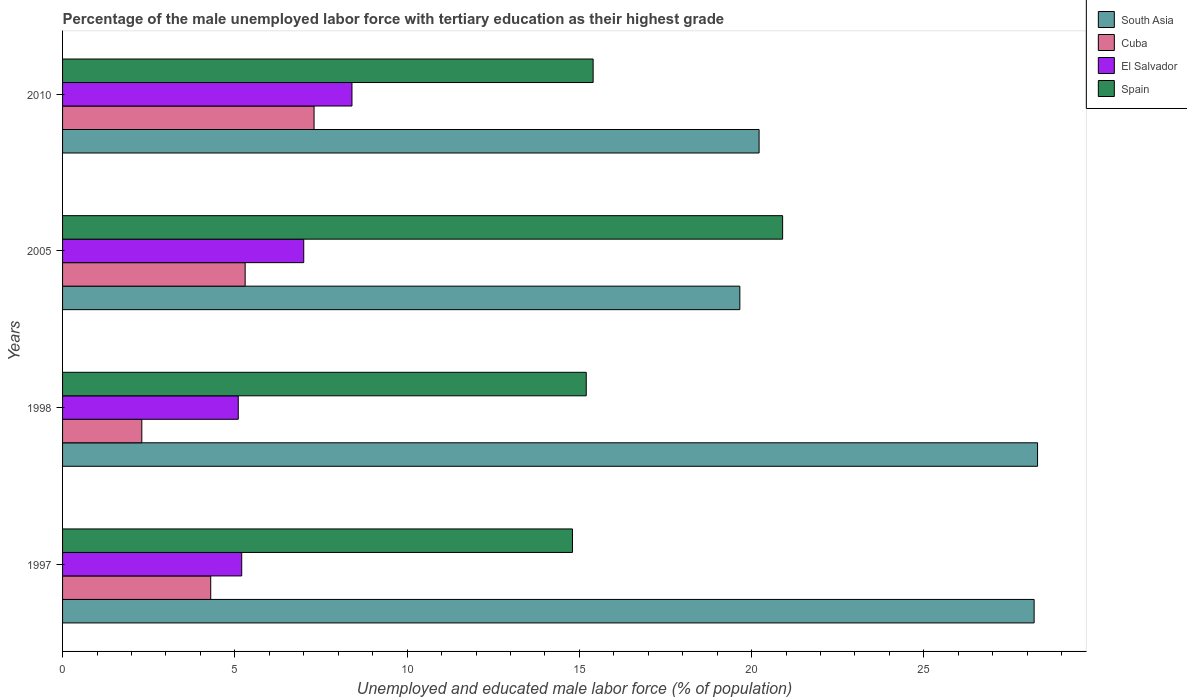How many different coloured bars are there?
Your answer should be compact. 4. How many groups of bars are there?
Offer a terse response. 4. Are the number of bars per tick equal to the number of legend labels?
Offer a terse response. Yes. Are the number of bars on each tick of the Y-axis equal?
Your response must be concise. Yes. How many bars are there on the 1st tick from the top?
Your answer should be compact. 4. In how many cases, is the number of bars for a given year not equal to the number of legend labels?
Your response must be concise. 0. What is the percentage of the unemployed male labor force with tertiary education in El Salvador in 2010?
Offer a terse response. 8.4. Across all years, what is the maximum percentage of the unemployed male labor force with tertiary education in El Salvador?
Offer a very short reply. 8.4. Across all years, what is the minimum percentage of the unemployed male labor force with tertiary education in South Asia?
Ensure brevity in your answer.  19.66. In which year was the percentage of the unemployed male labor force with tertiary education in Cuba minimum?
Your response must be concise. 1998. What is the total percentage of the unemployed male labor force with tertiary education in Spain in the graph?
Your answer should be compact. 66.3. What is the difference between the percentage of the unemployed male labor force with tertiary education in Cuba in 1997 and that in 1998?
Give a very brief answer. 2. What is the difference between the percentage of the unemployed male labor force with tertiary education in Spain in 2010 and the percentage of the unemployed male labor force with tertiary education in El Salvador in 1998?
Offer a very short reply. 10.3. What is the average percentage of the unemployed male labor force with tertiary education in South Asia per year?
Offer a very short reply. 24.09. In the year 1997, what is the difference between the percentage of the unemployed male labor force with tertiary education in Cuba and percentage of the unemployed male labor force with tertiary education in South Asia?
Your response must be concise. -23.9. What is the ratio of the percentage of the unemployed male labor force with tertiary education in Spain in 1998 to that in 2005?
Offer a very short reply. 0.73. What is the difference between the highest and the second highest percentage of the unemployed male labor force with tertiary education in Spain?
Your answer should be very brief. 5.5. What is the difference between the highest and the lowest percentage of the unemployed male labor force with tertiary education in Cuba?
Your answer should be compact. 5. In how many years, is the percentage of the unemployed male labor force with tertiary education in South Asia greater than the average percentage of the unemployed male labor force with tertiary education in South Asia taken over all years?
Make the answer very short. 2. What does the 4th bar from the bottom in 1998 represents?
Your answer should be compact. Spain. Is it the case that in every year, the sum of the percentage of the unemployed male labor force with tertiary education in El Salvador and percentage of the unemployed male labor force with tertiary education in Cuba is greater than the percentage of the unemployed male labor force with tertiary education in South Asia?
Offer a very short reply. No. How many bars are there?
Offer a very short reply. 16. Are all the bars in the graph horizontal?
Your answer should be very brief. Yes. How many years are there in the graph?
Offer a very short reply. 4. Are the values on the major ticks of X-axis written in scientific E-notation?
Offer a terse response. No. Does the graph contain grids?
Your response must be concise. No. What is the title of the graph?
Offer a terse response. Percentage of the male unemployed labor force with tertiary education as their highest grade. What is the label or title of the X-axis?
Provide a succinct answer. Unemployed and educated male labor force (% of population). What is the Unemployed and educated male labor force (% of population) in South Asia in 1997?
Offer a very short reply. 28.2. What is the Unemployed and educated male labor force (% of population) of Cuba in 1997?
Your response must be concise. 4.3. What is the Unemployed and educated male labor force (% of population) of El Salvador in 1997?
Offer a very short reply. 5.2. What is the Unemployed and educated male labor force (% of population) of Spain in 1997?
Offer a terse response. 14.8. What is the Unemployed and educated male labor force (% of population) of South Asia in 1998?
Your response must be concise. 28.3. What is the Unemployed and educated male labor force (% of population) of Cuba in 1998?
Give a very brief answer. 2.3. What is the Unemployed and educated male labor force (% of population) in El Salvador in 1998?
Offer a very short reply. 5.1. What is the Unemployed and educated male labor force (% of population) in Spain in 1998?
Give a very brief answer. 15.2. What is the Unemployed and educated male labor force (% of population) of South Asia in 2005?
Offer a terse response. 19.66. What is the Unemployed and educated male labor force (% of population) of Cuba in 2005?
Give a very brief answer. 5.3. What is the Unemployed and educated male labor force (% of population) in El Salvador in 2005?
Give a very brief answer. 7. What is the Unemployed and educated male labor force (% of population) of Spain in 2005?
Give a very brief answer. 20.9. What is the Unemployed and educated male labor force (% of population) of South Asia in 2010?
Your response must be concise. 20.22. What is the Unemployed and educated male labor force (% of population) in Cuba in 2010?
Ensure brevity in your answer.  7.3. What is the Unemployed and educated male labor force (% of population) of El Salvador in 2010?
Offer a very short reply. 8.4. What is the Unemployed and educated male labor force (% of population) in Spain in 2010?
Offer a terse response. 15.4. Across all years, what is the maximum Unemployed and educated male labor force (% of population) in South Asia?
Provide a short and direct response. 28.3. Across all years, what is the maximum Unemployed and educated male labor force (% of population) in Cuba?
Your answer should be very brief. 7.3. Across all years, what is the maximum Unemployed and educated male labor force (% of population) of El Salvador?
Provide a short and direct response. 8.4. Across all years, what is the maximum Unemployed and educated male labor force (% of population) of Spain?
Ensure brevity in your answer.  20.9. Across all years, what is the minimum Unemployed and educated male labor force (% of population) in South Asia?
Keep it short and to the point. 19.66. Across all years, what is the minimum Unemployed and educated male labor force (% of population) of Cuba?
Your response must be concise. 2.3. Across all years, what is the minimum Unemployed and educated male labor force (% of population) in El Salvador?
Offer a terse response. 5.1. Across all years, what is the minimum Unemployed and educated male labor force (% of population) of Spain?
Ensure brevity in your answer.  14.8. What is the total Unemployed and educated male labor force (% of population) in South Asia in the graph?
Offer a very short reply. 96.38. What is the total Unemployed and educated male labor force (% of population) in Cuba in the graph?
Provide a short and direct response. 19.2. What is the total Unemployed and educated male labor force (% of population) in El Salvador in the graph?
Keep it short and to the point. 25.7. What is the total Unemployed and educated male labor force (% of population) of Spain in the graph?
Your response must be concise. 66.3. What is the difference between the Unemployed and educated male labor force (% of population) in El Salvador in 1997 and that in 1998?
Your response must be concise. 0.1. What is the difference between the Unemployed and educated male labor force (% of population) of Spain in 1997 and that in 1998?
Your answer should be compact. -0.4. What is the difference between the Unemployed and educated male labor force (% of population) of South Asia in 1997 and that in 2005?
Ensure brevity in your answer.  8.54. What is the difference between the Unemployed and educated male labor force (% of population) in Cuba in 1997 and that in 2005?
Keep it short and to the point. -1. What is the difference between the Unemployed and educated male labor force (% of population) in El Salvador in 1997 and that in 2005?
Offer a terse response. -1.8. What is the difference between the Unemployed and educated male labor force (% of population) in South Asia in 1997 and that in 2010?
Your answer should be compact. 7.98. What is the difference between the Unemployed and educated male labor force (% of population) in South Asia in 1998 and that in 2005?
Ensure brevity in your answer.  8.64. What is the difference between the Unemployed and educated male labor force (% of population) in Cuba in 1998 and that in 2005?
Ensure brevity in your answer.  -3. What is the difference between the Unemployed and educated male labor force (% of population) in Spain in 1998 and that in 2005?
Offer a very short reply. -5.7. What is the difference between the Unemployed and educated male labor force (% of population) of South Asia in 1998 and that in 2010?
Make the answer very short. 8.08. What is the difference between the Unemployed and educated male labor force (% of population) of Spain in 1998 and that in 2010?
Your answer should be compact. -0.2. What is the difference between the Unemployed and educated male labor force (% of population) in South Asia in 2005 and that in 2010?
Your answer should be very brief. -0.56. What is the difference between the Unemployed and educated male labor force (% of population) of Cuba in 2005 and that in 2010?
Keep it short and to the point. -2. What is the difference between the Unemployed and educated male labor force (% of population) of El Salvador in 2005 and that in 2010?
Give a very brief answer. -1.4. What is the difference between the Unemployed and educated male labor force (% of population) of Spain in 2005 and that in 2010?
Make the answer very short. 5.5. What is the difference between the Unemployed and educated male labor force (% of population) in South Asia in 1997 and the Unemployed and educated male labor force (% of population) in Cuba in 1998?
Your answer should be very brief. 25.9. What is the difference between the Unemployed and educated male labor force (% of population) in South Asia in 1997 and the Unemployed and educated male labor force (% of population) in El Salvador in 1998?
Give a very brief answer. 23.1. What is the difference between the Unemployed and educated male labor force (% of population) of Cuba in 1997 and the Unemployed and educated male labor force (% of population) of El Salvador in 1998?
Provide a succinct answer. -0.8. What is the difference between the Unemployed and educated male labor force (% of population) in Cuba in 1997 and the Unemployed and educated male labor force (% of population) in Spain in 1998?
Your answer should be compact. -10.9. What is the difference between the Unemployed and educated male labor force (% of population) of South Asia in 1997 and the Unemployed and educated male labor force (% of population) of Cuba in 2005?
Provide a short and direct response. 22.9. What is the difference between the Unemployed and educated male labor force (% of population) of South Asia in 1997 and the Unemployed and educated male labor force (% of population) of El Salvador in 2005?
Provide a short and direct response. 21.2. What is the difference between the Unemployed and educated male labor force (% of population) of Cuba in 1997 and the Unemployed and educated male labor force (% of population) of El Salvador in 2005?
Give a very brief answer. -2.7. What is the difference between the Unemployed and educated male labor force (% of population) of Cuba in 1997 and the Unemployed and educated male labor force (% of population) of Spain in 2005?
Give a very brief answer. -16.6. What is the difference between the Unemployed and educated male labor force (% of population) in El Salvador in 1997 and the Unemployed and educated male labor force (% of population) in Spain in 2005?
Your answer should be very brief. -15.7. What is the difference between the Unemployed and educated male labor force (% of population) of South Asia in 1997 and the Unemployed and educated male labor force (% of population) of Cuba in 2010?
Give a very brief answer. 20.9. What is the difference between the Unemployed and educated male labor force (% of population) of South Asia in 1997 and the Unemployed and educated male labor force (% of population) of El Salvador in 2010?
Provide a short and direct response. 19.8. What is the difference between the Unemployed and educated male labor force (% of population) in El Salvador in 1997 and the Unemployed and educated male labor force (% of population) in Spain in 2010?
Your response must be concise. -10.2. What is the difference between the Unemployed and educated male labor force (% of population) of South Asia in 1998 and the Unemployed and educated male labor force (% of population) of El Salvador in 2005?
Ensure brevity in your answer.  21.3. What is the difference between the Unemployed and educated male labor force (% of population) in South Asia in 1998 and the Unemployed and educated male labor force (% of population) in Spain in 2005?
Your answer should be very brief. 7.4. What is the difference between the Unemployed and educated male labor force (% of population) in Cuba in 1998 and the Unemployed and educated male labor force (% of population) in El Salvador in 2005?
Your response must be concise. -4.7. What is the difference between the Unemployed and educated male labor force (% of population) of Cuba in 1998 and the Unemployed and educated male labor force (% of population) of Spain in 2005?
Offer a terse response. -18.6. What is the difference between the Unemployed and educated male labor force (% of population) of El Salvador in 1998 and the Unemployed and educated male labor force (% of population) of Spain in 2005?
Offer a terse response. -15.8. What is the difference between the Unemployed and educated male labor force (% of population) in South Asia in 1998 and the Unemployed and educated male labor force (% of population) in Spain in 2010?
Offer a terse response. 12.9. What is the difference between the Unemployed and educated male labor force (% of population) of South Asia in 2005 and the Unemployed and educated male labor force (% of population) of Cuba in 2010?
Make the answer very short. 12.36. What is the difference between the Unemployed and educated male labor force (% of population) in South Asia in 2005 and the Unemployed and educated male labor force (% of population) in El Salvador in 2010?
Offer a terse response. 11.26. What is the difference between the Unemployed and educated male labor force (% of population) of South Asia in 2005 and the Unemployed and educated male labor force (% of population) of Spain in 2010?
Make the answer very short. 4.26. What is the difference between the Unemployed and educated male labor force (% of population) in Cuba in 2005 and the Unemployed and educated male labor force (% of population) in El Salvador in 2010?
Ensure brevity in your answer.  -3.1. What is the difference between the Unemployed and educated male labor force (% of population) in El Salvador in 2005 and the Unemployed and educated male labor force (% of population) in Spain in 2010?
Your answer should be compact. -8.4. What is the average Unemployed and educated male labor force (% of population) of South Asia per year?
Keep it short and to the point. 24.09. What is the average Unemployed and educated male labor force (% of population) in Cuba per year?
Your answer should be very brief. 4.8. What is the average Unemployed and educated male labor force (% of population) in El Salvador per year?
Give a very brief answer. 6.42. What is the average Unemployed and educated male labor force (% of population) in Spain per year?
Ensure brevity in your answer.  16.57. In the year 1997, what is the difference between the Unemployed and educated male labor force (% of population) in South Asia and Unemployed and educated male labor force (% of population) in Cuba?
Your answer should be very brief. 23.9. In the year 1997, what is the difference between the Unemployed and educated male labor force (% of population) of South Asia and Unemployed and educated male labor force (% of population) of El Salvador?
Provide a succinct answer. 23. In the year 1997, what is the difference between the Unemployed and educated male labor force (% of population) of South Asia and Unemployed and educated male labor force (% of population) of Spain?
Offer a very short reply. 13.4. In the year 1997, what is the difference between the Unemployed and educated male labor force (% of population) in Cuba and Unemployed and educated male labor force (% of population) in El Salvador?
Offer a terse response. -0.9. In the year 1997, what is the difference between the Unemployed and educated male labor force (% of population) in Cuba and Unemployed and educated male labor force (% of population) in Spain?
Your response must be concise. -10.5. In the year 1998, what is the difference between the Unemployed and educated male labor force (% of population) in South Asia and Unemployed and educated male labor force (% of population) in Cuba?
Provide a succinct answer. 26. In the year 1998, what is the difference between the Unemployed and educated male labor force (% of population) in South Asia and Unemployed and educated male labor force (% of population) in El Salvador?
Provide a succinct answer. 23.2. In the year 1998, what is the difference between the Unemployed and educated male labor force (% of population) of South Asia and Unemployed and educated male labor force (% of population) of Spain?
Provide a short and direct response. 13.1. In the year 1998, what is the difference between the Unemployed and educated male labor force (% of population) of Cuba and Unemployed and educated male labor force (% of population) of El Salvador?
Keep it short and to the point. -2.8. In the year 1998, what is the difference between the Unemployed and educated male labor force (% of population) of Cuba and Unemployed and educated male labor force (% of population) of Spain?
Give a very brief answer. -12.9. In the year 1998, what is the difference between the Unemployed and educated male labor force (% of population) in El Salvador and Unemployed and educated male labor force (% of population) in Spain?
Offer a very short reply. -10.1. In the year 2005, what is the difference between the Unemployed and educated male labor force (% of population) of South Asia and Unemployed and educated male labor force (% of population) of Cuba?
Ensure brevity in your answer.  14.36. In the year 2005, what is the difference between the Unemployed and educated male labor force (% of population) of South Asia and Unemployed and educated male labor force (% of population) of El Salvador?
Ensure brevity in your answer.  12.66. In the year 2005, what is the difference between the Unemployed and educated male labor force (% of population) in South Asia and Unemployed and educated male labor force (% of population) in Spain?
Provide a short and direct response. -1.24. In the year 2005, what is the difference between the Unemployed and educated male labor force (% of population) in Cuba and Unemployed and educated male labor force (% of population) in Spain?
Offer a terse response. -15.6. In the year 2010, what is the difference between the Unemployed and educated male labor force (% of population) in South Asia and Unemployed and educated male labor force (% of population) in Cuba?
Your response must be concise. 12.92. In the year 2010, what is the difference between the Unemployed and educated male labor force (% of population) in South Asia and Unemployed and educated male labor force (% of population) in El Salvador?
Provide a short and direct response. 11.82. In the year 2010, what is the difference between the Unemployed and educated male labor force (% of population) in South Asia and Unemployed and educated male labor force (% of population) in Spain?
Provide a succinct answer. 4.82. In the year 2010, what is the difference between the Unemployed and educated male labor force (% of population) in Cuba and Unemployed and educated male labor force (% of population) in El Salvador?
Give a very brief answer. -1.1. What is the ratio of the Unemployed and educated male labor force (% of population) in South Asia in 1997 to that in 1998?
Ensure brevity in your answer.  1. What is the ratio of the Unemployed and educated male labor force (% of population) in Cuba in 1997 to that in 1998?
Provide a short and direct response. 1.87. What is the ratio of the Unemployed and educated male labor force (% of population) of El Salvador in 1997 to that in 1998?
Keep it short and to the point. 1.02. What is the ratio of the Unemployed and educated male labor force (% of population) in Spain in 1997 to that in 1998?
Give a very brief answer. 0.97. What is the ratio of the Unemployed and educated male labor force (% of population) of South Asia in 1997 to that in 2005?
Your response must be concise. 1.43. What is the ratio of the Unemployed and educated male labor force (% of population) of Cuba in 1997 to that in 2005?
Your answer should be very brief. 0.81. What is the ratio of the Unemployed and educated male labor force (% of population) in El Salvador in 1997 to that in 2005?
Offer a very short reply. 0.74. What is the ratio of the Unemployed and educated male labor force (% of population) in Spain in 1997 to that in 2005?
Make the answer very short. 0.71. What is the ratio of the Unemployed and educated male labor force (% of population) of South Asia in 1997 to that in 2010?
Ensure brevity in your answer.  1.39. What is the ratio of the Unemployed and educated male labor force (% of population) of Cuba in 1997 to that in 2010?
Ensure brevity in your answer.  0.59. What is the ratio of the Unemployed and educated male labor force (% of population) in El Salvador in 1997 to that in 2010?
Provide a short and direct response. 0.62. What is the ratio of the Unemployed and educated male labor force (% of population) in South Asia in 1998 to that in 2005?
Give a very brief answer. 1.44. What is the ratio of the Unemployed and educated male labor force (% of population) in Cuba in 1998 to that in 2005?
Your answer should be very brief. 0.43. What is the ratio of the Unemployed and educated male labor force (% of population) in El Salvador in 1998 to that in 2005?
Make the answer very short. 0.73. What is the ratio of the Unemployed and educated male labor force (% of population) of Spain in 1998 to that in 2005?
Provide a succinct answer. 0.73. What is the ratio of the Unemployed and educated male labor force (% of population) in South Asia in 1998 to that in 2010?
Your answer should be compact. 1.4. What is the ratio of the Unemployed and educated male labor force (% of population) of Cuba in 1998 to that in 2010?
Your answer should be very brief. 0.32. What is the ratio of the Unemployed and educated male labor force (% of population) of El Salvador in 1998 to that in 2010?
Offer a very short reply. 0.61. What is the ratio of the Unemployed and educated male labor force (% of population) in South Asia in 2005 to that in 2010?
Offer a very short reply. 0.97. What is the ratio of the Unemployed and educated male labor force (% of population) in Cuba in 2005 to that in 2010?
Make the answer very short. 0.73. What is the ratio of the Unemployed and educated male labor force (% of population) of Spain in 2005 to that in 2010?
Ensure brevity in your answer.  1.36. What is the difference between the highest and the second highest Unemployed and educated male labor force (% of population) in South Asia?
Give a very brief answer. 0.1. What is the difference between the highest and the second highest Unemployed and educated male labor force (% of population) in Cuba?
Your response must be concise. 2. What is the difference between the highest and the second highest Unemployed and educated male labor force (% of population) of Spain?
Offer a terse response. 5.5. What is the difference between the highest and the lowest Unemployed and educated male labor force (% of population) of South Asia?
Ensure brevity in your answer.  8.64. What is the difference between the highest and the lowest Unemployed and educated male labor force (% of population) in Cuba?
Your response must be concise. 5. 